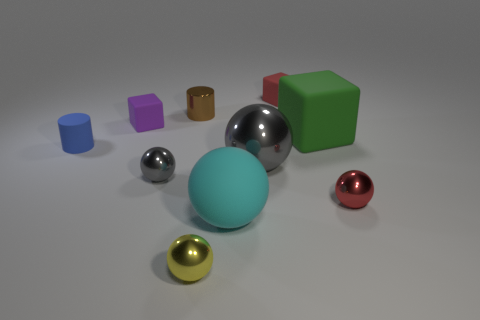Subtract 2 cubes. How many cubes are left? 1 Subtract all gray balls. How many balls are left? 3 Subtract all purple cubes. How many cubes are left? 2 Subtract 1 red blocks. How many objects are left? 9 Subtract all blocks. How many objects are left? 7 Subtract all blue cylinders. Subtract all brown blocks. How many cylinders are left? 1 Subtract all green cylinders. How many cyan balls are left? 1 Subtract all large purple matte cubes. Subtract all big objects. How many objects are left? 7 Add 3 green blocks. How many green blocks are left? 4 Add 4 tiny blue cylinders. How many tiny blue cylinders exist? 5 